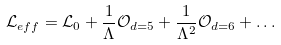Convert formula to latex. <formula><loc_0><loc_0><loc_500><loc_500>\mathcal { L } _ { e f f } = \mathcal { L } _ { 0 } + \frac { 1 } { \Lambda } \mathcal { O } _ { d = 5 } + \frac { 1 } { \Lambda ^ { 2 } } \mathcal { O } _ { d = 6 } + \dots</formula> 